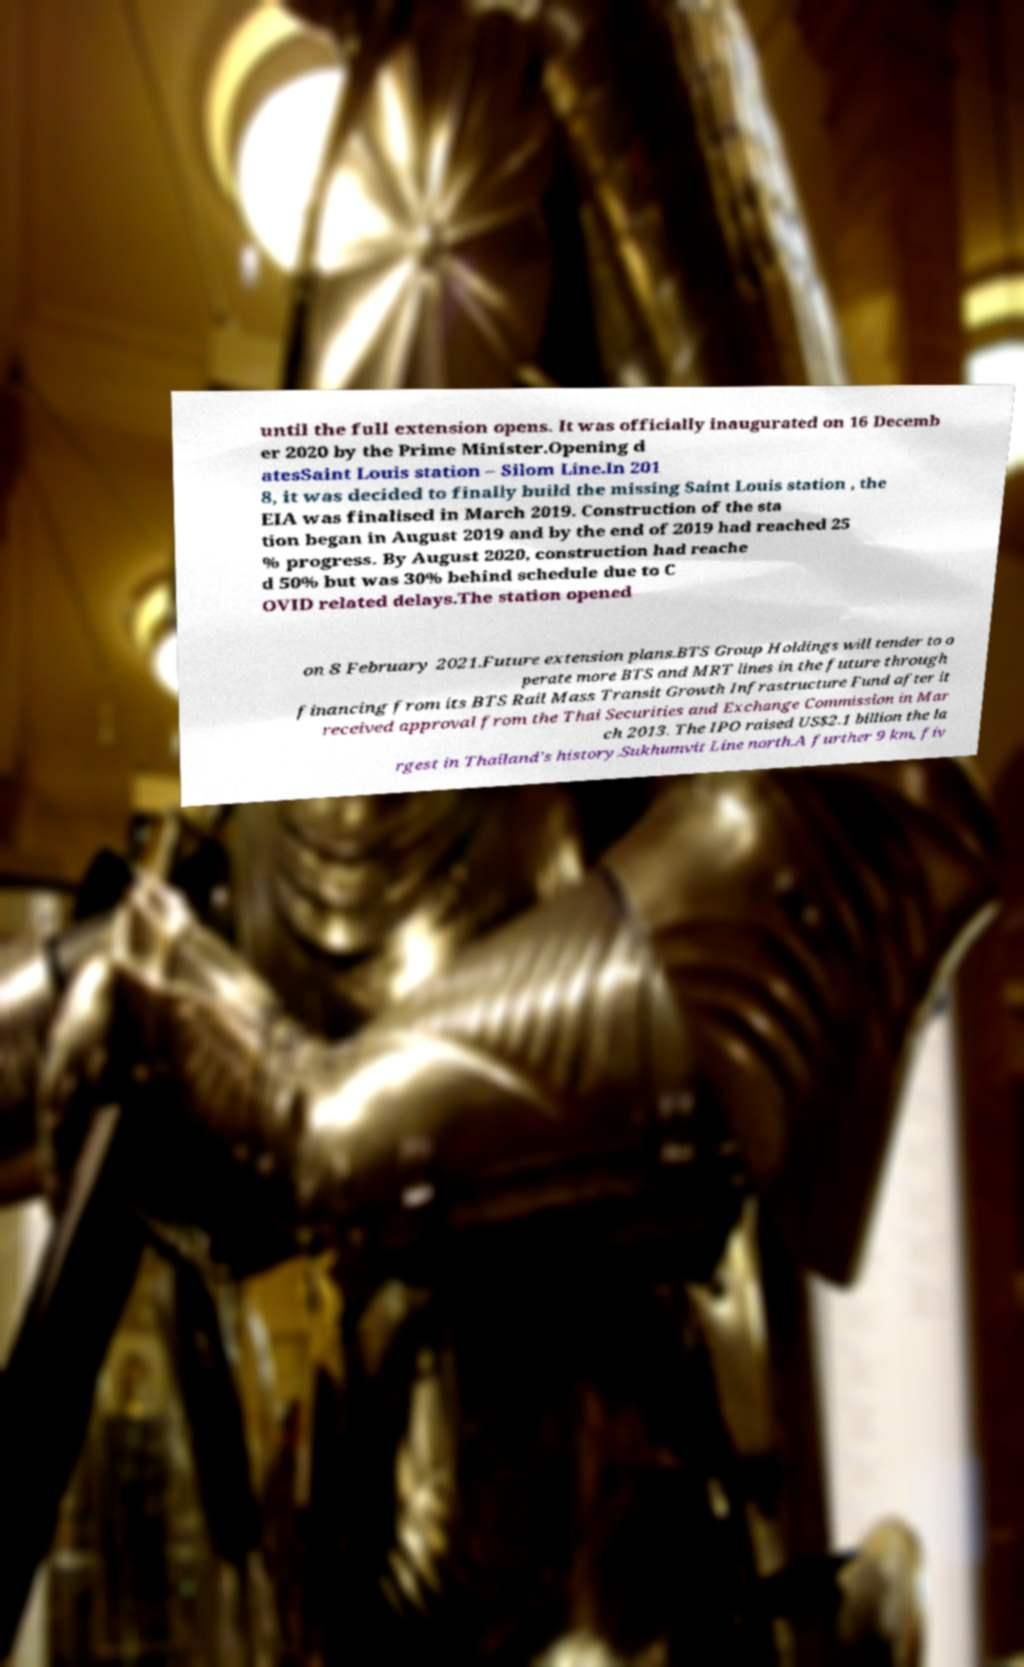For documentation purposes, I need the text within this image transcribed. Could you provide that? until the full extension opens. It was officially inaugurated on 16 Decemb er 2020 by the Prime Minister.Opening d atesSaint Louis station – Silom Line.In 201 8, it was decided to finally build the missing Saint Louis station , the EIA was finalised in March 2019. Construction of the sta tion began in August 2019 and by the end of 2019 had reached 25 % progress. By August 2020, construction had reache d 50% but was 30% behind schedule due to C OVID related delays.The station opened on 8 February 2021.Future extension plans.BTS Group Holdings will tender to o perate more BTS and MRT lines in the future through financing from its BTS Rail Mass Transit Growth Infrastructure Fund after it received approval from the Thai Securities and Exchange Commission in Mar ch 2013. The IPO raised US$2.1 billion the la rgest in Thailand's history.Sukhumvit Line north.A further 9 km, fiv 